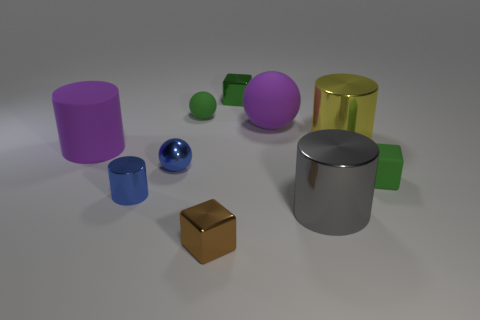If these objects were to be used in a game, what could their purposes be? In a game context, these objects could serve multiple purposes: the cylinders and cubes may act as building blocks for construction, the spheres might be used as rolling elements in puzzle challenges, and the reflective materials could be part of aesthetics to enhance visual interest or to indicate special interactive objects. 